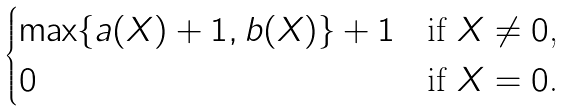<formula> <loc_0><loc_0><loc_500><loc_500>\begin{cases} \max \{ a ( X ) + 1 , b ( X ) \} + 1 & \text {if $X \ne 0$,} \\ 0 & \text {if $X = 0$.} \end{cases}</formula> 